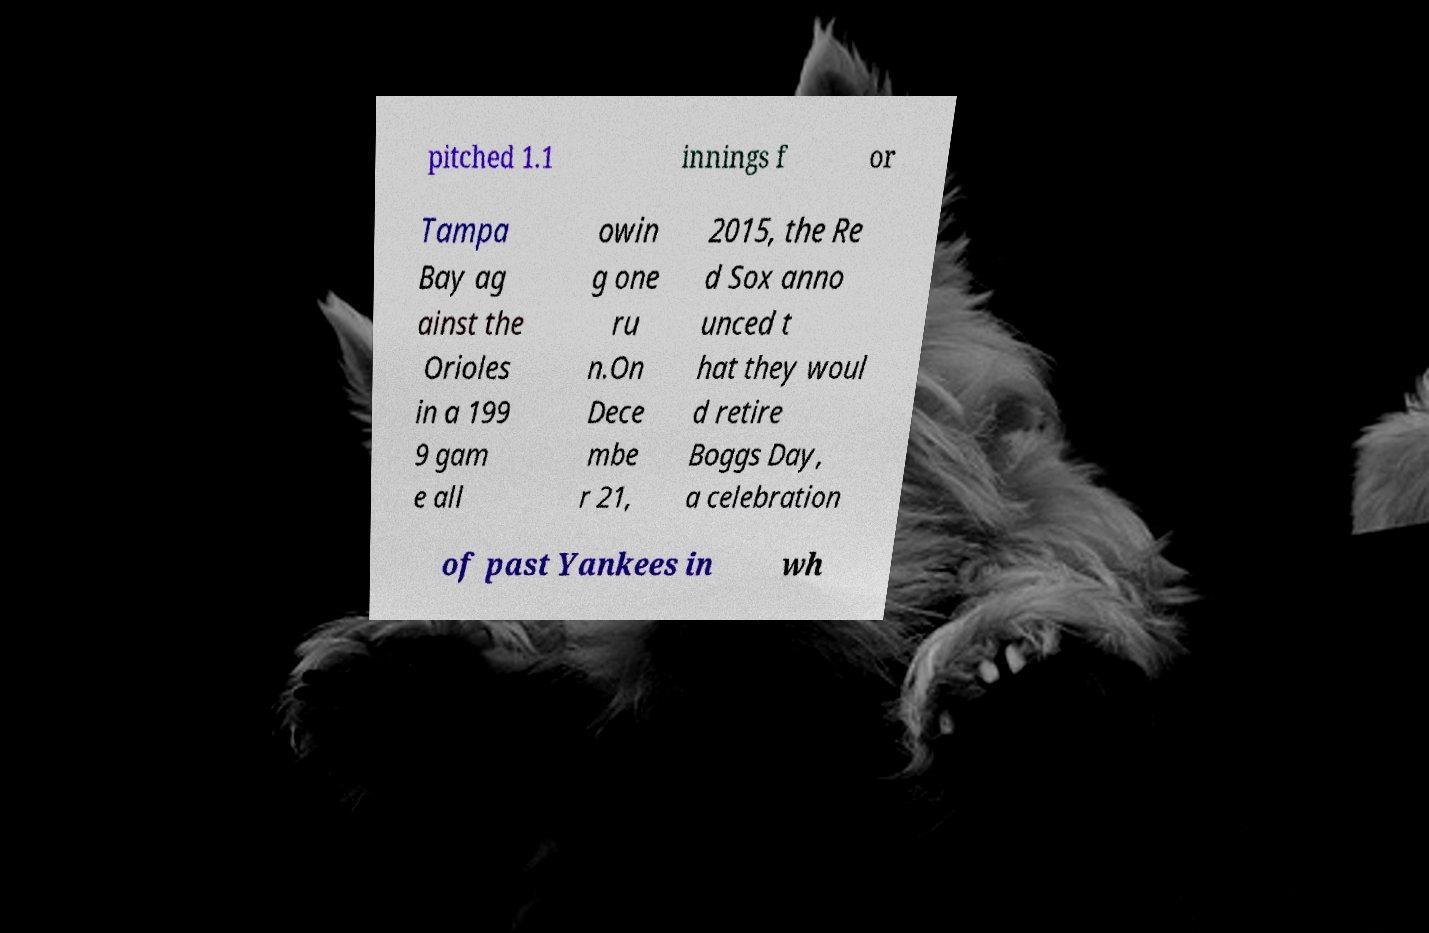I need the written content from this picture converted into text. Can you do that? pitched 1.1 innings f or Tampa Bay ag ainst the Orioles in a 199 9 gam e all owin g one ru n.On Dece mbe r 21, 2015, the Re d Sox anno unced t hat they woul d retire Boggs Day, a celebration of past Yankees in wh 